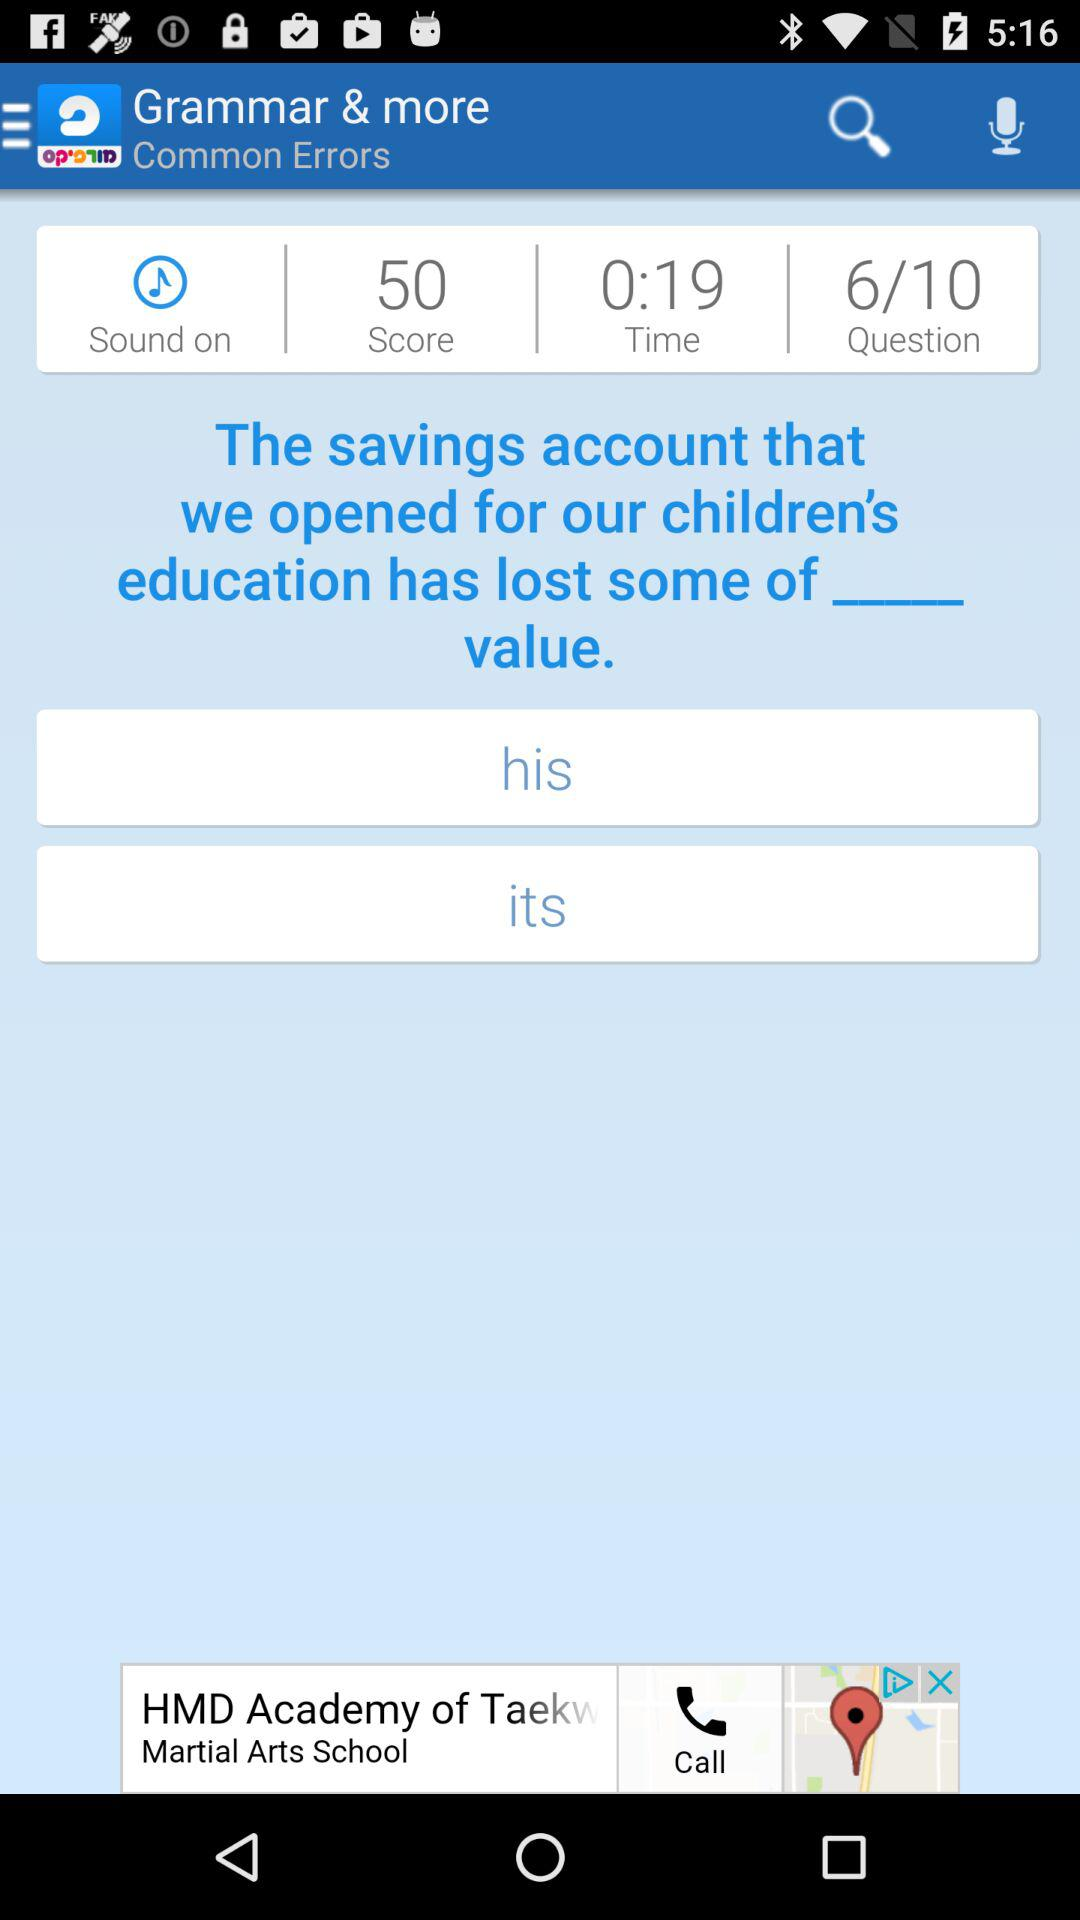What is the application name? The application name is "Morfix - English to Hebrew Translator & Dictionary". 